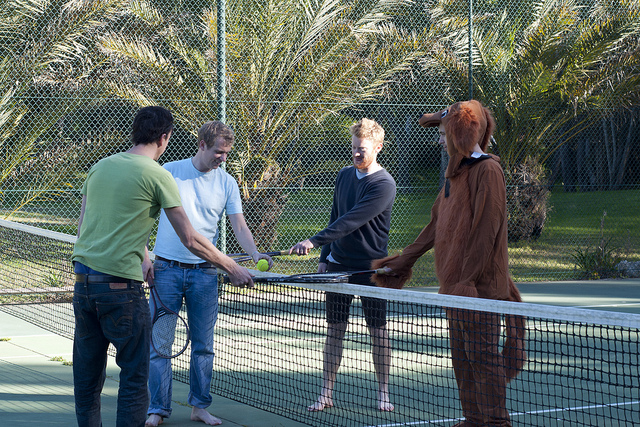Please provide a short description for this region: [0.22, 0.36, 0.42, 0.83]. A man wearing a white t-shirt. 